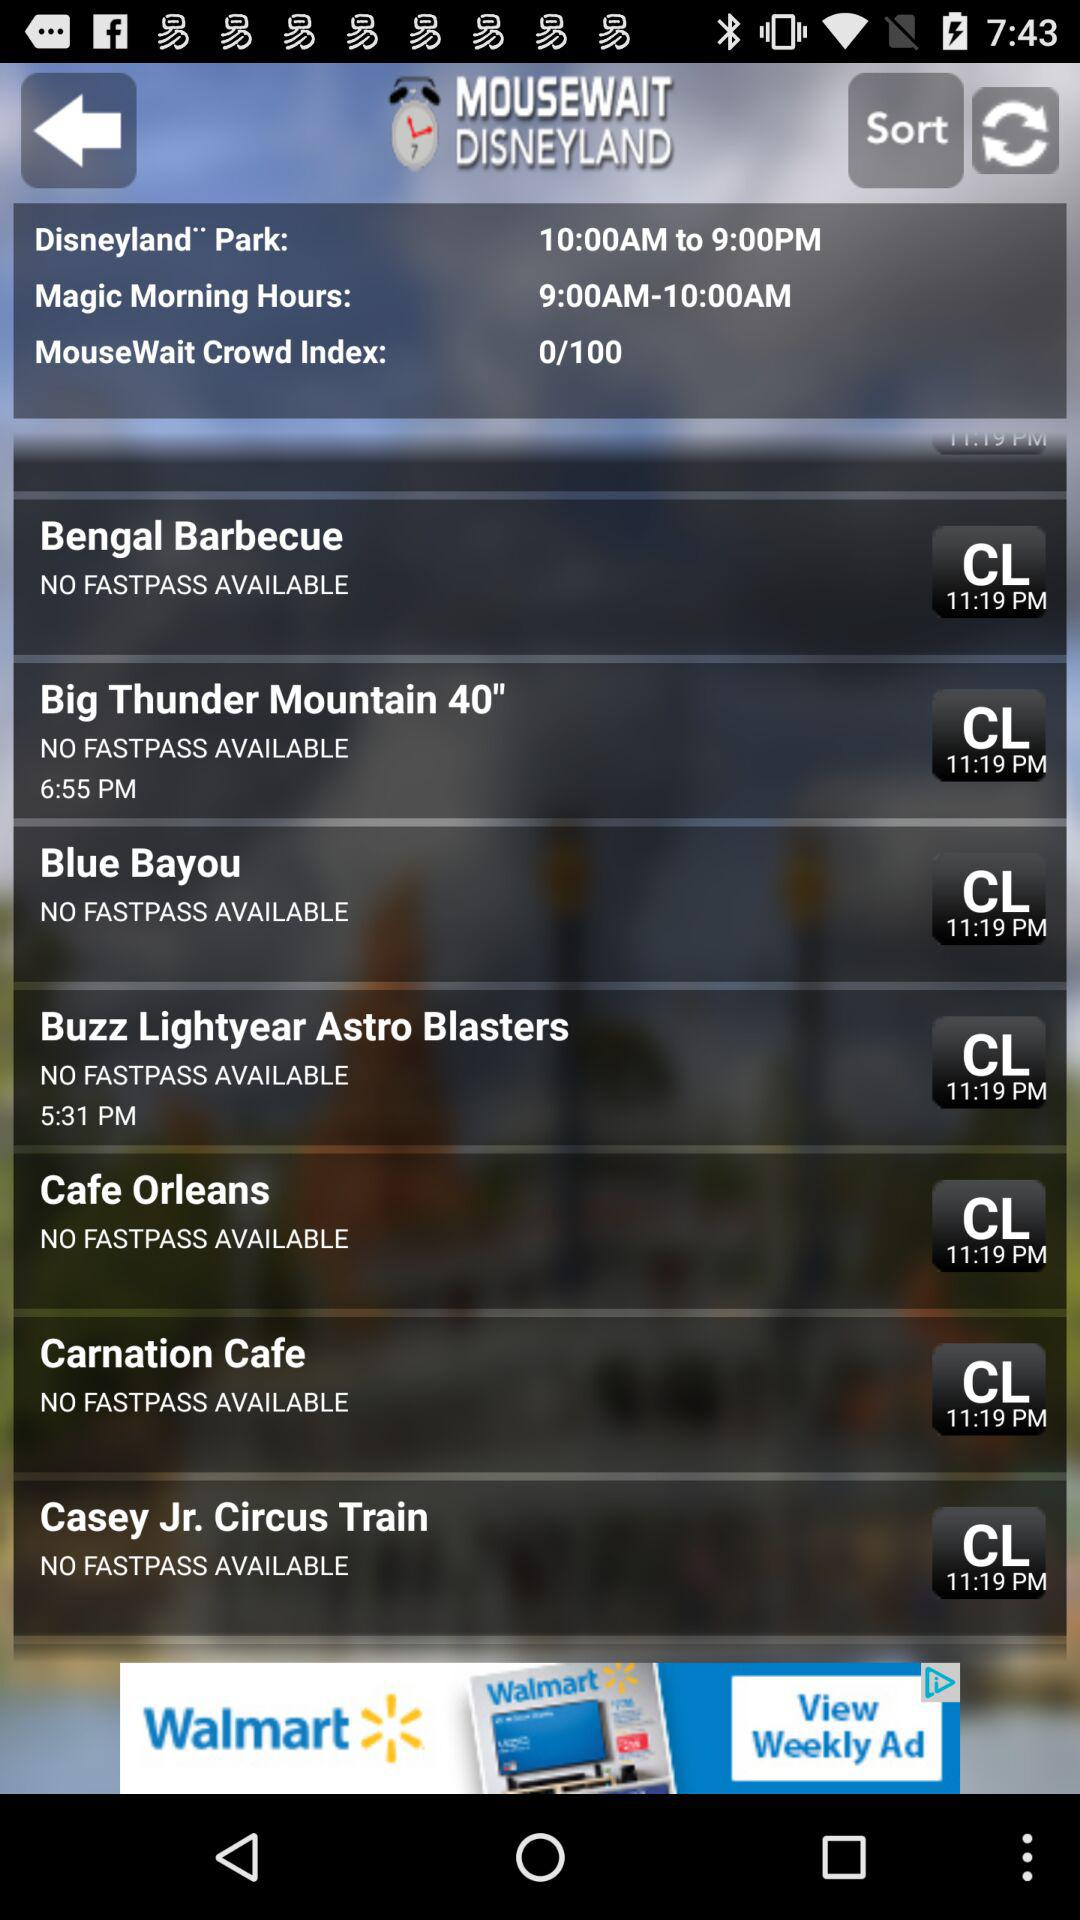What is the name of the application? The name of the application is "MOUSEWAIT DISNEYLAND". 